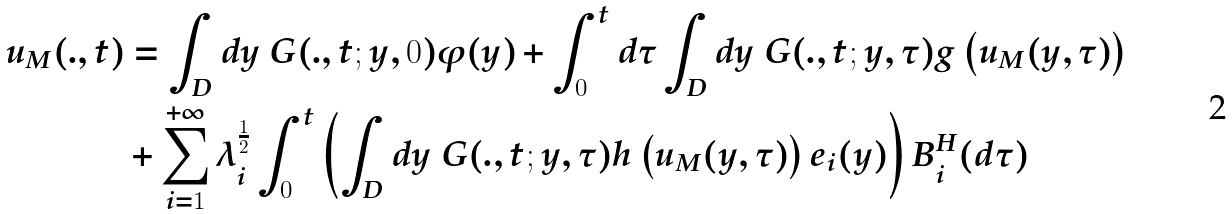Convert formula to latex. <formula><loc_0><loc_0><loc_500><loc_500>u _ { M } ( . , t ) & = \int _ { D } d y \ G ( . , t ; y , 0 ) \varphi ( y ) + \int _ { 0 } ^ { t } d \tau \int _ { D } d y \ G ( . , t ; y , \tau ) g \left ( u _ { M } ( y , \tau ) \right ) \\ & + \sum _ { i = 1 } ^ { + \infty } \lambda _ { i } ^ { \frac { 1 } { 2 } } \int _ { 0 } ^ { t } \left ( \int _ { D } d y \ G ( . , t ; y , \tau ) h \left ( u _ { M } ( y , \tau ) \right ) e _ { i } ( y ) \right ) B _ { i } ^ { H } ( d \tau )</formula> 